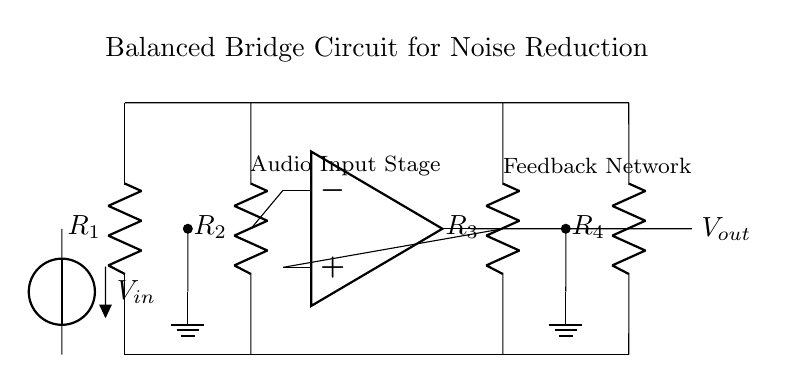What components are present in this circuit? The circuit diagram shows resistors, an operational amplifier, a voltage source, and ground connections. Specifically, there are four resistors labeled R1, R2, R3, and R4, as well as a voltage source labeled Vin and an op-amp.
Answer: Resistors, operational amplifier, voltage source What is the role of the operational amplifier in this circuit? The operational amplifier amplifies the difference between the input signals received from the two resistor branches (R2 and R3). It helps reduce noise by balancing the input voltages and providing better signal fidelity for audio applications.
Answer: Amplification How many resistors are connected in total in this circuit? The diagram indicates that there are four resistors connected in the balanced bridge configuration, designated as R1, R2, R3, and R4. These resistors are integral to the noise reduction function of the circuit.
Answer: Four Which resistors are connected to the input of the operational amplifier? The resistors R2 and R3 are connected to the negative and positive inputs of the operational amplifier, respectively. This configuration allows the op-amp to process the voltage difference between these two resistors.
Answer: R2 and R3 What is the significance of the ground connections in this circuit? Ground connections provide a reference point for the circuit's voltage measurements and stability. They help eliminate noise and ensure proper functioning by establishing a common return path for currents in the circuit.
Answer: Reference point What does the output voltage represent in this balanced bridge circuit? The output voltage, Vout, represents the amplified and processed output signal that reduces noise, enhancing the overall audio quality by reflecting the determined differences in input voltages from the resistors.
Answer: Processed output signal 